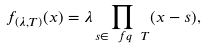<formula> <loc_0><loc_0><loc_500><loc_500>f _ { ( \lambda , T ) } ( x ) = \lambda \prod _ { s \in \ f q \ T } ( x - s ) ,</formula> 